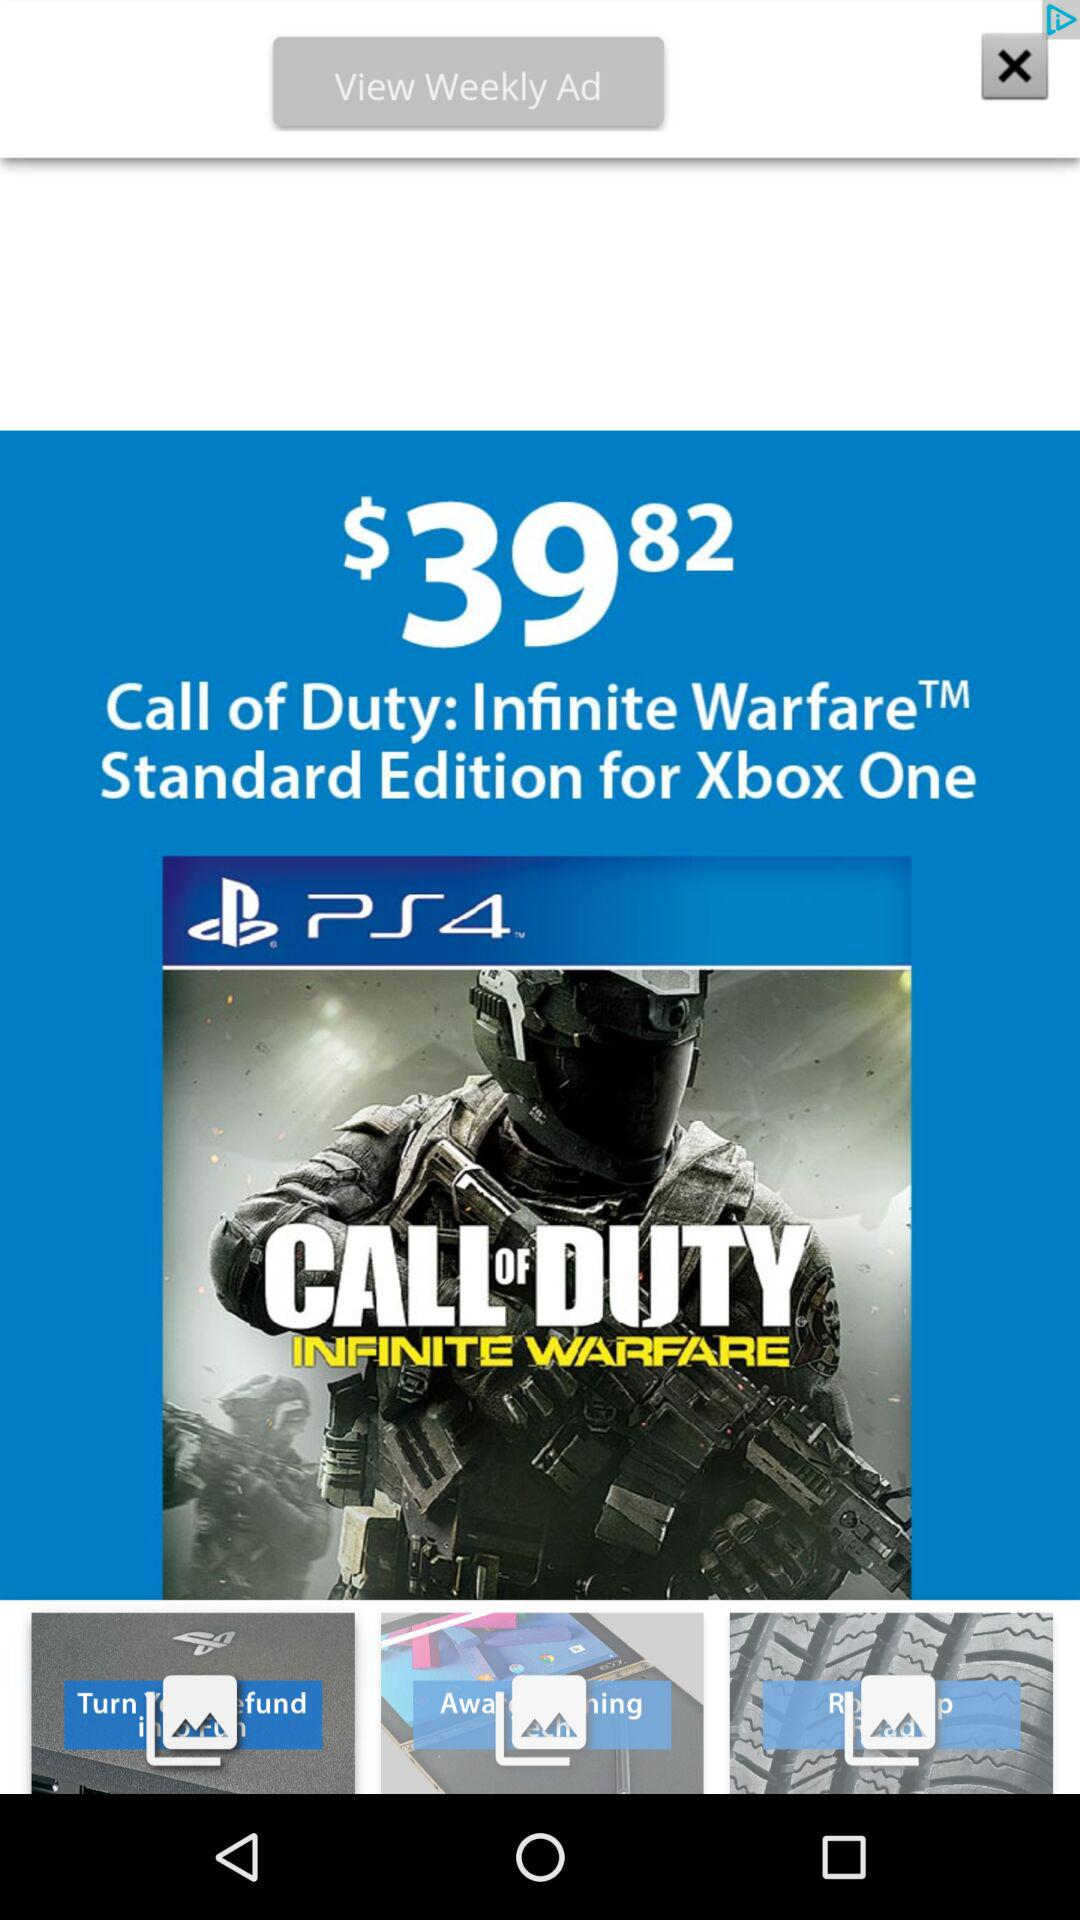When was "Call of Duty: Infinite Warfare" released?
When the provided information is insufficient, respond with <no answer>. <no answer> 